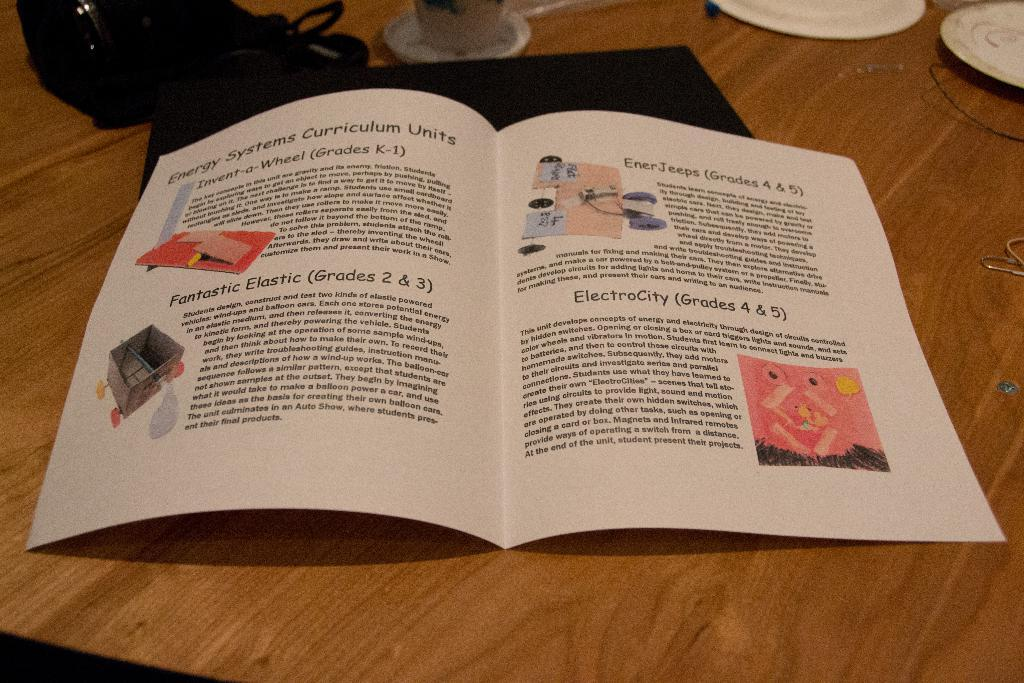<image>
Give a short and clear explanation of the subsequent image. Paper on a table that contains energy system curriculum units 